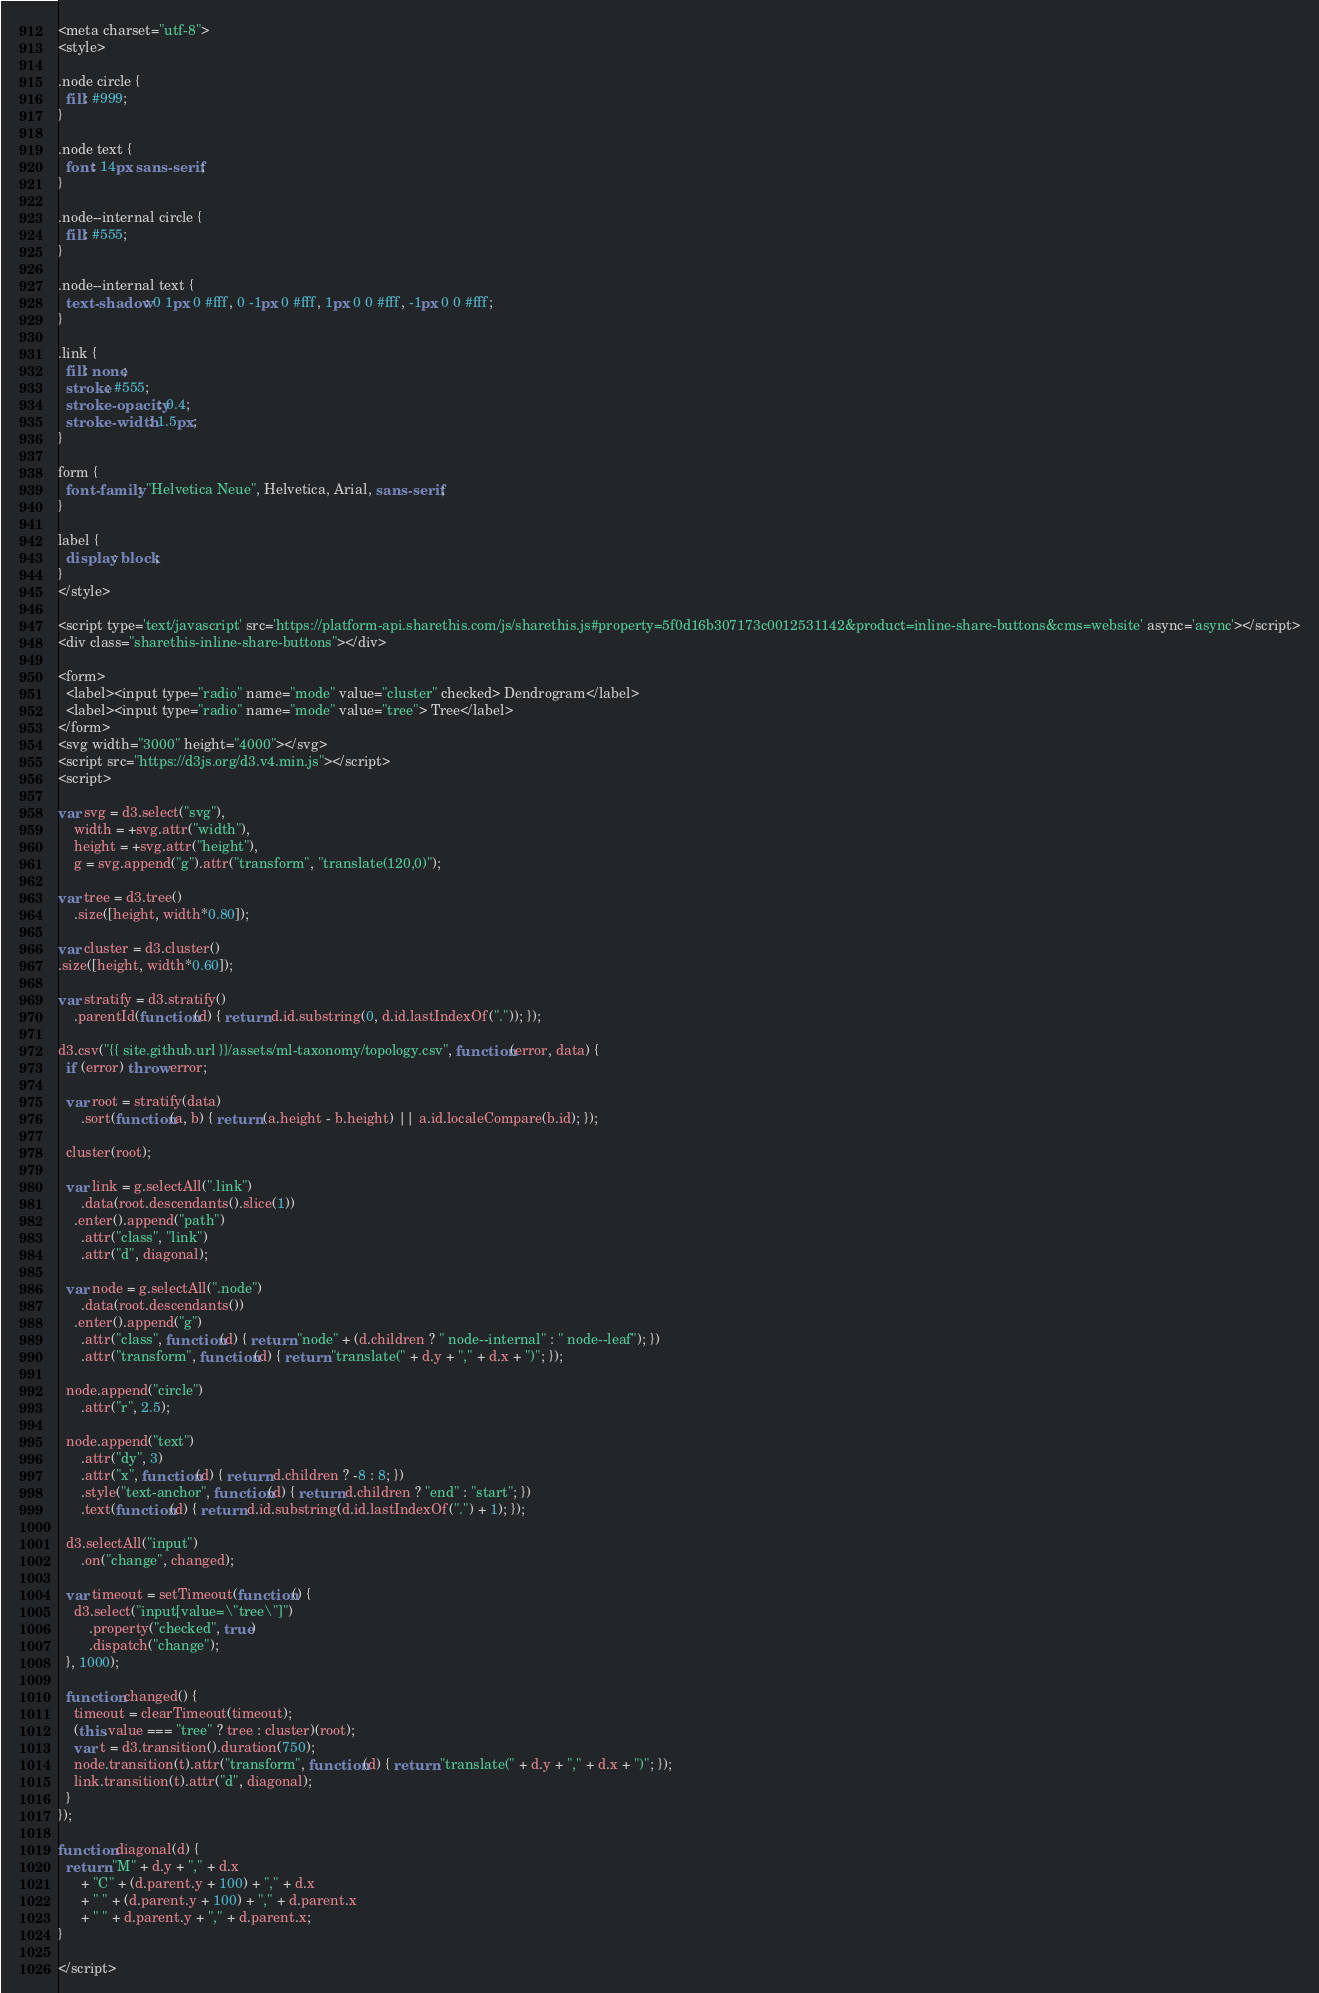<code> <loc_0><loc_0><loc_500><loc_500><_HTML_><meta charset="utf-8">
<style>

.node circle {
  fill: #999;
}

.node text {
  font: 14px sans-serif;
}

.node--internal circle {
  fill: #555;
}

.node--internal text {
  text-shadow: 0 1px 0 #fff, 0 -1px 0 #fff, 1px 0 0 #fff, -1px 0 0 #fff;
}

.link {
  fill: none;
  stroke: #555;
  stroke-opacity: 0.4;
  stroke-width: 1.5px;
}

form {
  font-family: "Helvetica Neue", Helvetica, Arial, sans-serif;
}

label {
  display: block;
}
</style>

<script type='text/javascript' src='https://platform-api.sharethis.com/js/sharethis.js#property=5f0d16b307173c0012531142&product=inline-share-buttons&cms=website' async='async'></script>
<div class="sharethis-inline-share-buttons"></div>

<form>
  <label><input type="radio" name="mode" value="cluster" checked> Dendrogram</label>
  <label><input type="radio" name="mode" value="tree"> Tree</label>
</form>
<svg width="3000" height="4000"></svg>
<script src="https://d3js.org/d3.v4.min.js"></script>
<script>

var svg = d3.select("svg"),
    width = +svg.attr("width"),
    height = +svg.attr("height"),
    g = svg.append("g").attr("transform", "translate(120,0)");

var tree = d3.tree()
    .size([height, width*0.80]);

var cluster = d3.cluster()
.size([height, width*0.60]);

var stratify = d3.stratify()
    .parentId(function(d) { return d.id.substring(0, d.id.lastIndexOf(".")); });

d3.csv("{{ site.github.url }}/assets/ml-taxonomy/topology.csv", function(error, data) {
  if (error) throw error;

  var root = stratify(data)
      .sort(function(a, b) { return (a.height - b.height) || a.id.localeCompare(b.id); });

  cluster(root);

  var link = g.selectAll(".link")
      .data(root.descendants().slice(1))
    .enter().append("path")
      .attr("class", "link")
      .attr("d", diagonal);

  var node = g.selectAll(".node")
      .data(root.descendants())
    .enter().append("g")
      .attr("class", function(d) { return "node" + (d.children ? " node--internal" : " node--leaf"); })
      .attr("transform", function(d) { return "translate(" + d.y + "," + d.x + ")"; });

  node.append("circle")
      .attr("r", 2.5);

  node.append("text")
      .attr("dy", 3)
      .attr("x", function(d) { return d.children ? -8 : 8; })
      .style("text-anchor", function(d) { return d.children ? "end" : "start"; })
      .text(function(d) { return d.id.substring(d.id.lastIndexOf(".") + 1); });

  d3.selectAll("input")
      .on("change", changed);

  var timeout = setTimeout(function() {
    d3.select("input[value=\"tree\"]")
        .property("checked", true)
        .dispatch("change");
  }, 1000);

  function changed() {
    timeout = clearTimeout(timeout);
    (this.value === "tree" ? tree : cluster)(root);
    var t = d3.transition().duration(750);
    node.transition(t).attr("transform", function(d) { return "translate(" + d.y + "," + d.x + ")"; });
    link.transition(t).attr("d", diagonal);
  }
});

function diagonal(d) {
  return "M" + d.y + "," + d.x
      + "C" + (d.parent.y + 100) + "," + d.x
      + " " + (d.parent.y + 100) + "," + d.parent.x
      + " " + d.parent.y + "," + d.parent.x;
}

</script>
</code> 